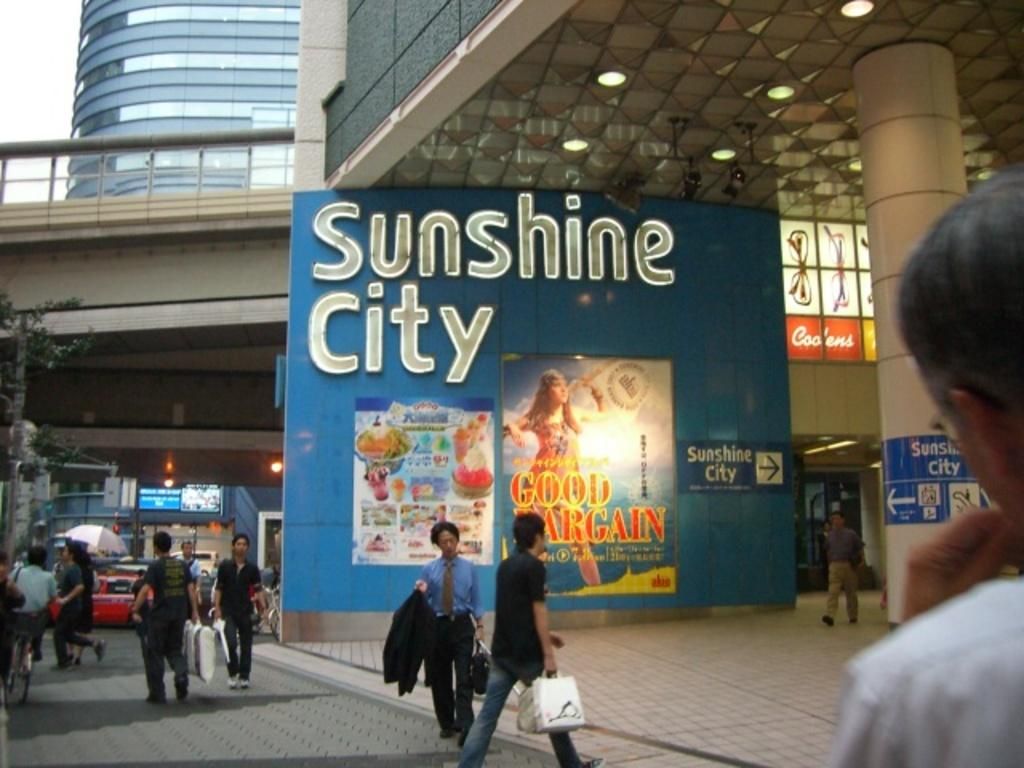Provide a one-sentence caption for the provided image. A big Sunshine City sign on the side of a building. 